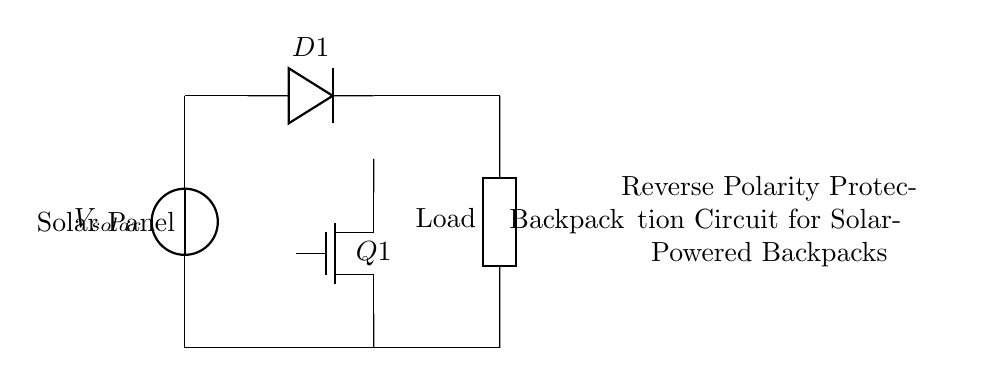What is the role of the diode in this circuit? The diode (D1) allows current to flow in only one direction, which prevents reverse polarity when connecting the solar panel to the load. This means if the connections are made incorrectly, the diode will block current, protecting the circuit.
Answer: Allows current in one direction What type of load is indicated in this circuit? The circuit shows a load labeled generically as "Load," which can be any device powered by the solar backpack, typically an electronic device. The actual specifications of the load would depend on the application of the backpack.
Answer: Generic load What is the type of MOSFET used in this circuit? The circuit diagram specifies the MOSFET as a "Tnmos," which means it is an N-channel MOSFET. These types are commonly used for switching applications in low-side control.
Answer: N-channel MOSFET How many main components are used in this reverse polarity protection circuit? The main components in this circuit diagram are two: the diode and the MOSFET. In total, there is also the solar panel and the load, but in terms of protection components, there are just the diode and MOSFET.
Answer: Two What happens if the solar panel is connected with reverse polarity? If the solar panel is connected with reverse polarity, the diode (D1) will block the current flow, preventing damage to the circuit components, including the load and the MOSFET. Hence, no current will reach the backpack, safeguarding it.
Answer: Current is blocked What is connected between the solar panel and the load? The circuit shows that the diode (D1) is connected between the solar panel and the load. This diode ensures that current flows in the correct direction to protect the load from reverse polarity.
Answer: The diode What does the 'Q1' label represent in the circuit? The label 'Q1' represents the N-channel MOSFET in the circuit. This component is typically used to switch the load on and off based on the control signal received, which is part of the reverse polarity protection mechanism.
Answer: N-channel MOSFET 